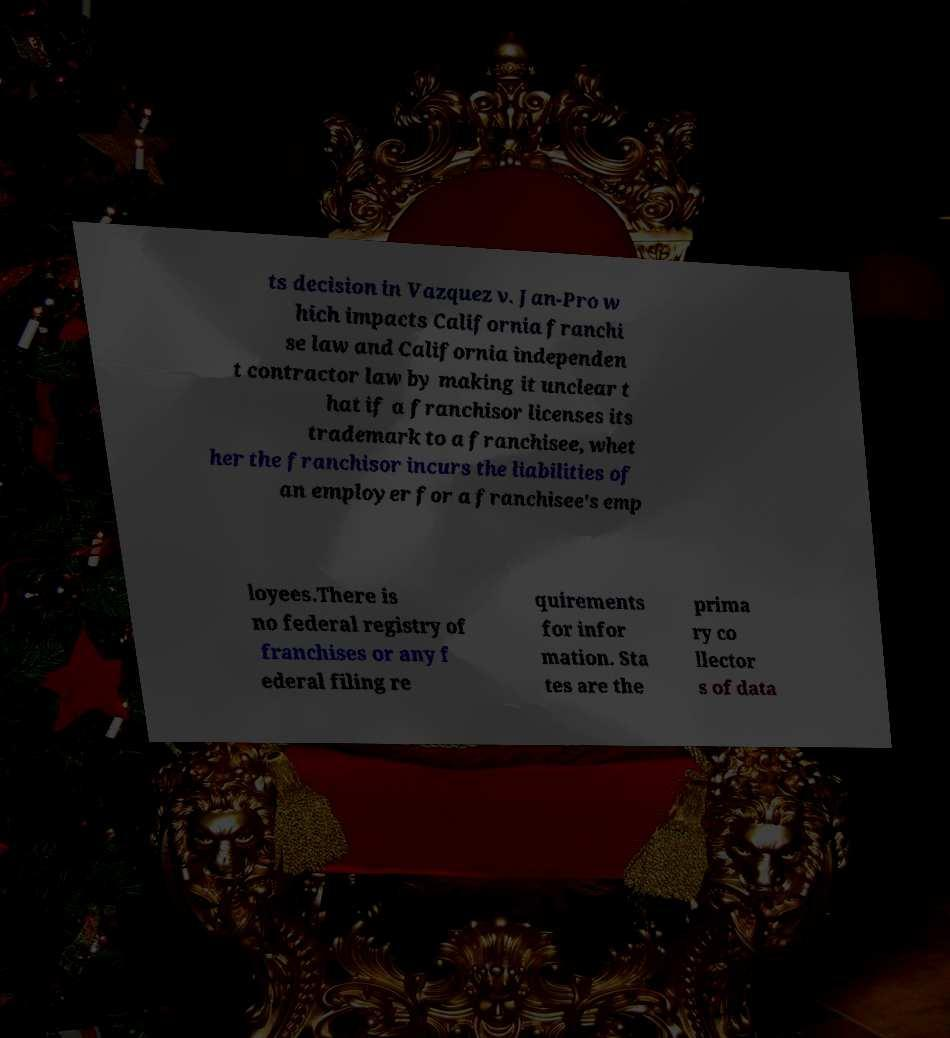For documentation purposes, I need the text within this image transcribed. Could you provide that? ts decision in Vazquez v. Jan-Pro w hich impacts California franchi se law and California independen t contractor law by making it unclear t hat if a franchisor licenses its trademark to a franchisee, whet her the franchisor incurs the liabilities of an employer for a franchisee's emp loyees.There is no federal registry of franchises or any f ederal filing re quirements for infor mation. Sta tes are the prima ry co llector s of data 